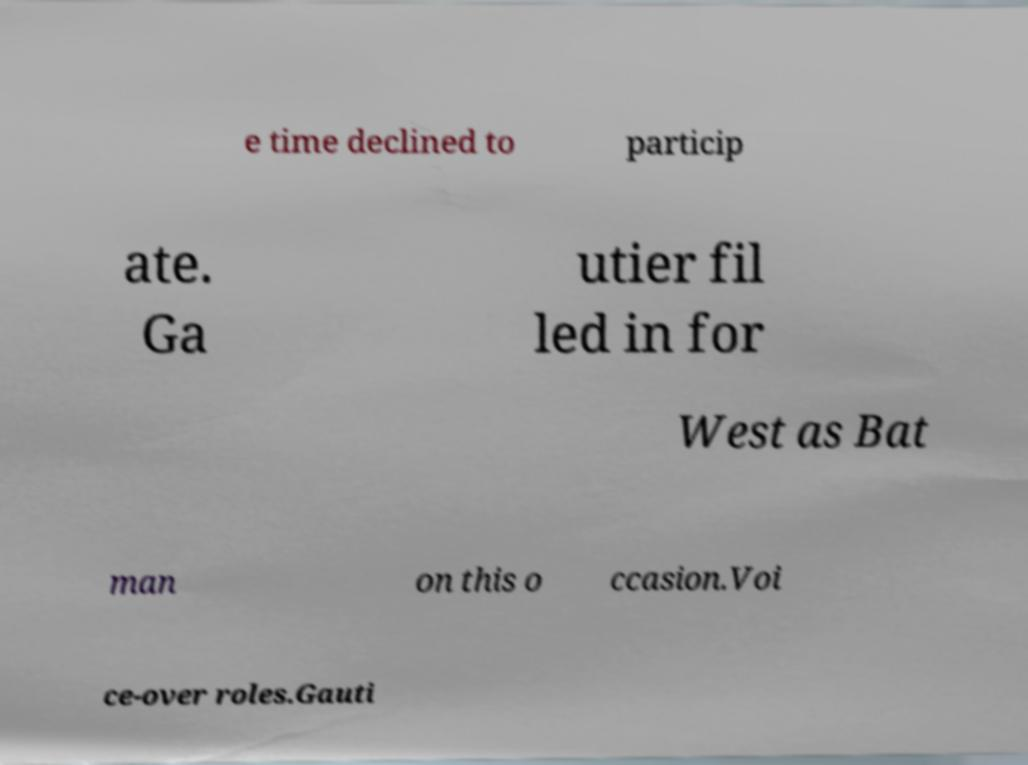For documentation purposes, I need the text within this image transcribed. Could you provide that? e time declined to particip ate. Ga utier fil led in for West as Bat man on this o ccasion.Voi ce-over roles.Gauti 